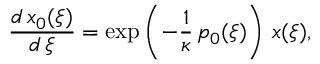Convert formula to latex. <formula><loc_0><loc_0><loc_500><loc_500>\frac { d \, x _ { 0 } ( \xi ) } { d \, \xi } = \exp \left ( - \frac { 1 } { \kappa } \, p _ { 0 } ( \xi ) \right ) \, x ( \xi ) ,</formula> 